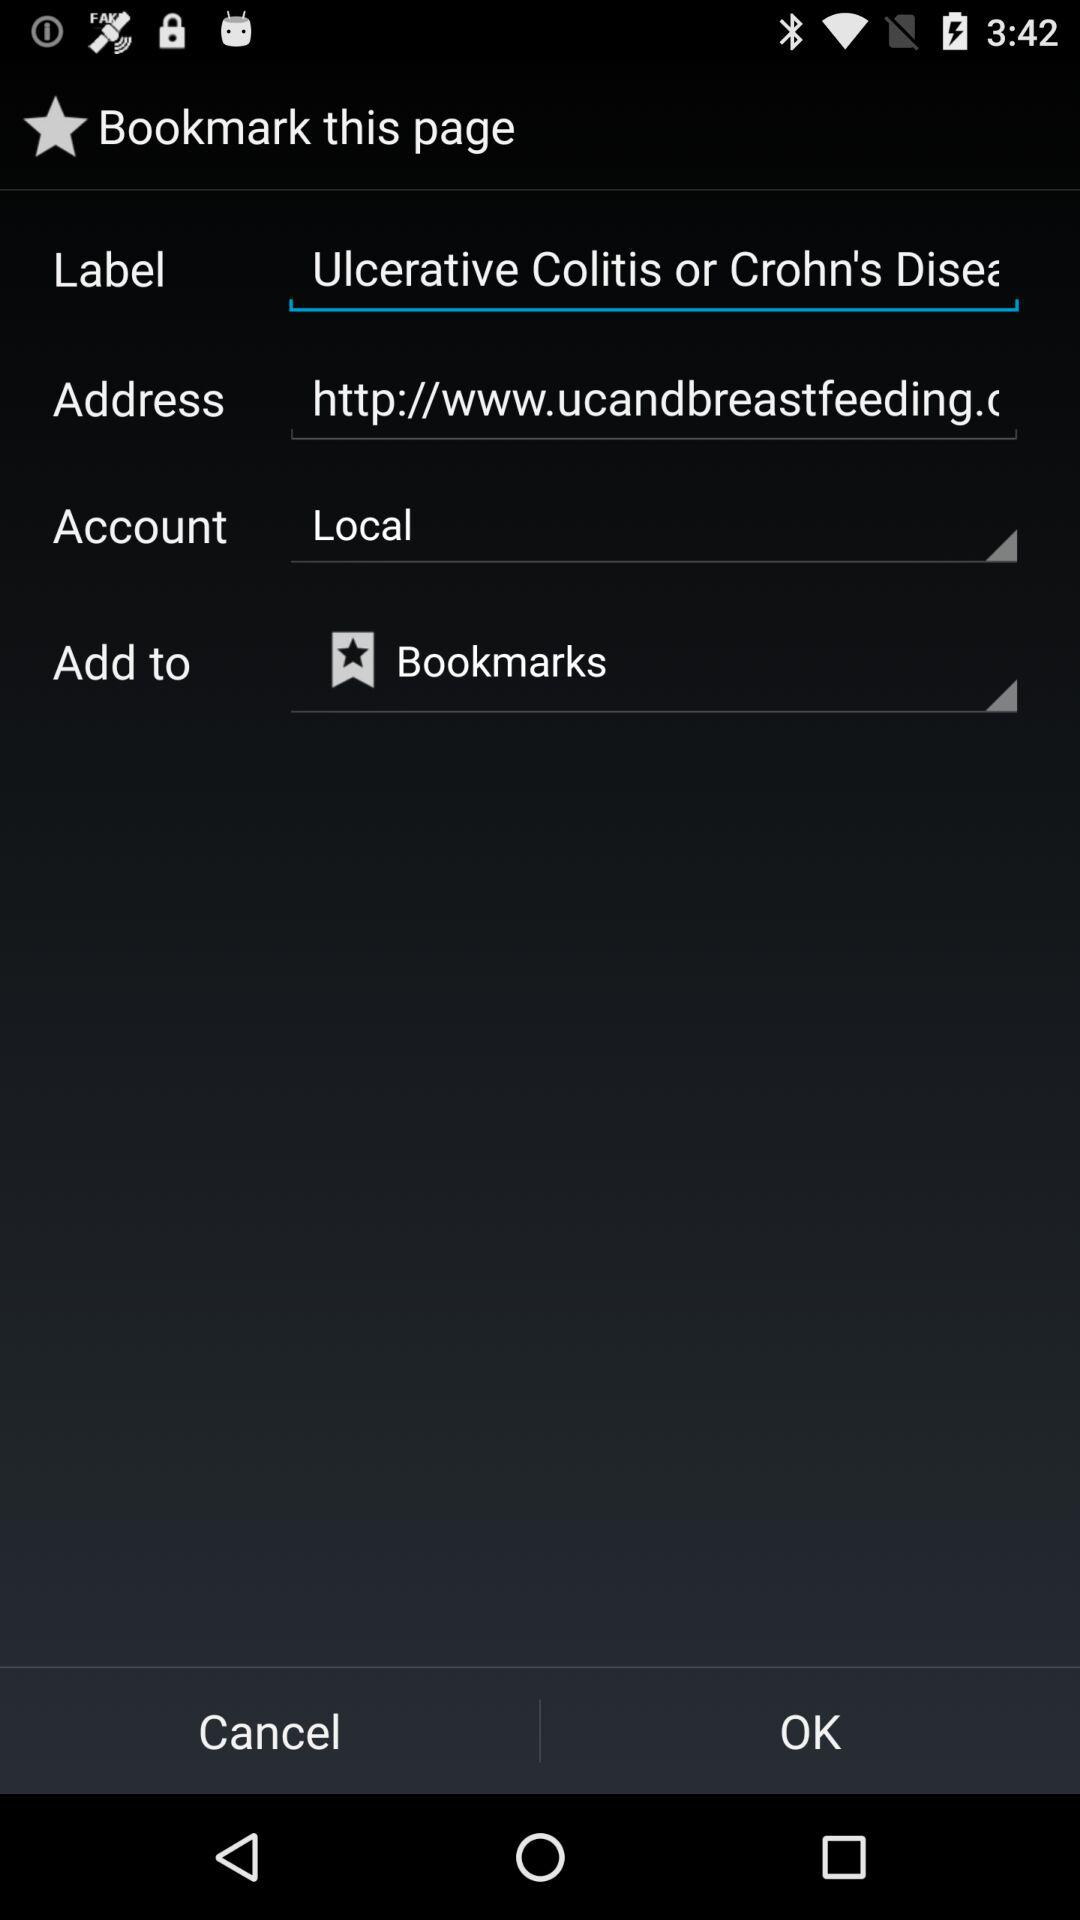How many text inputs have the text 'Local' in them?
Answer the question using a single word or phrase. 1 